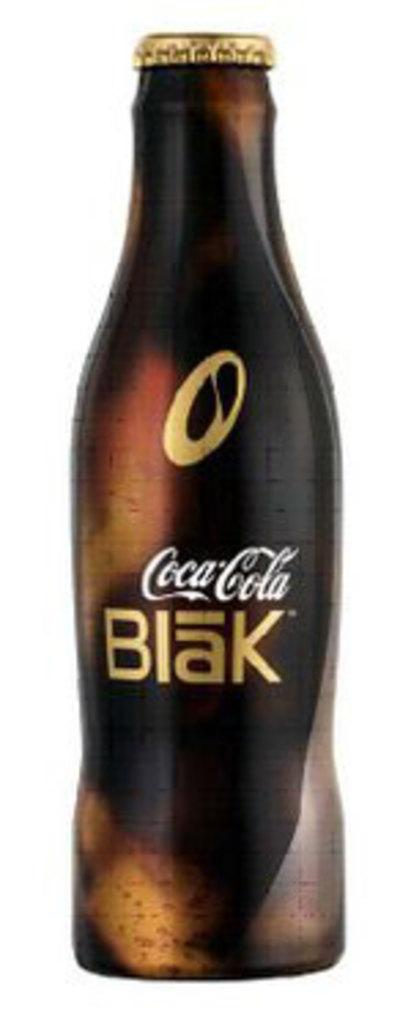<image>
Render a clear and concise summary of the photo. A full bottle of coca cola blak on a white background. 